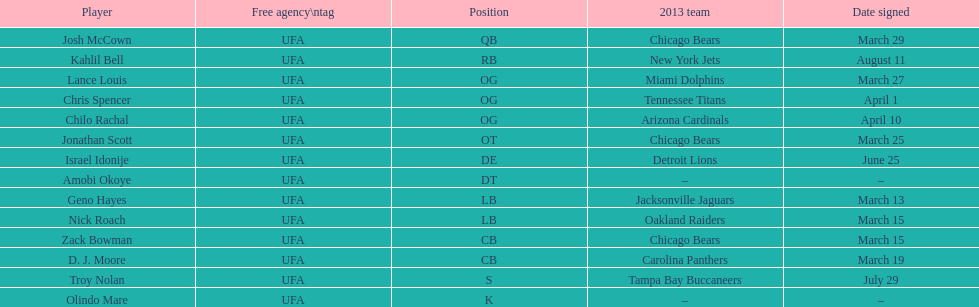Signed the same day as "april 1st pranks." Chris Spencer. 